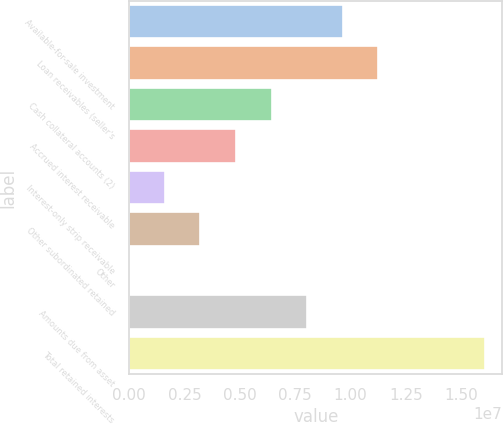Convert chart to OTSL. <chart><loc_0><loc_0><loc_500><loc_500><bar_chart><fcel>Available-for-sale investment<fcel>Loan receivables (seller's<fcel>Cash collateral accounts (2)<fcel>Accrued interest receivable<fcel>Interest-only strip receivable<fcel>Other subordinated retained<fcel>Other<fcel>Amounts due from asset<fcel>Total retained interests<nl><fcel>9.63224e+06<fcel>1.12356e+07<fcel>6.4256e+06<fcel>4.82228e+06<fcel>1.61564e+06<fcel>3.21896e+06<fcel>12324<fcel>8.02892e+06<fcel>1.60455e+07<nl></chart> 